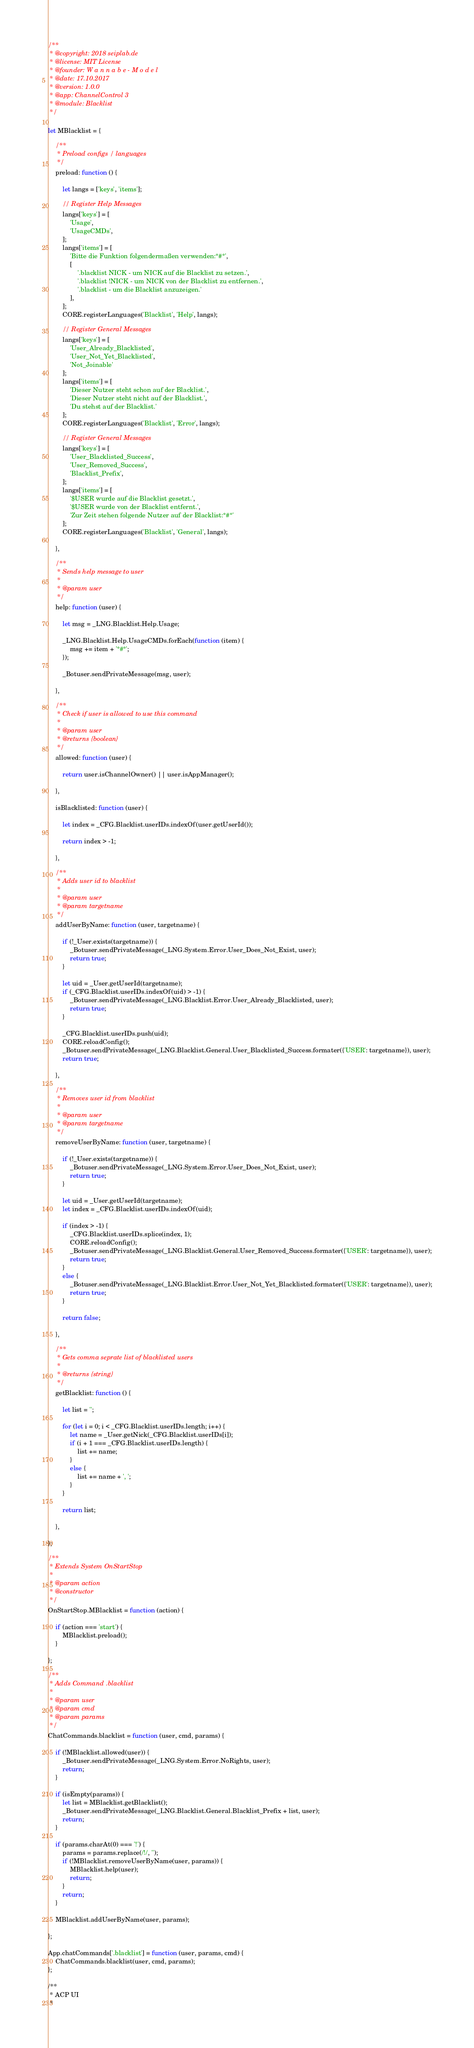<code> <loc_0><loc_0><loc_500><loc_500><_JavaScript_>/**
 * @copyright: 2018 seiplab.de
 * @license: MIT License
 * @founder: W a n n a b e - M o d e l
 * @date: 17.10.2017
 * @version: 1.0.0
 * @app: ChannelControl 3
 * @module: Blacklist
 */

let MBlacklist = {

    /**
     * Preload configs / languages
     */
    preload: function () {

        let langs = ['keys', 'items'];

        // Register Help Messages
        langs['keys'] = [
            'Usage',
            'UsageCMDs',
        ];
        langs['items'] = [
            'Bitte die Funktion folgendermaßen verwenden:°#°',
            [
                '.blacklist NICK - um NICK auf die Blacklist zu setzen.',
                '.blacklist !NICK - um NICK von der Blacklist zu entfernen.',
                '.blacklist - um die Blacklist anzuzeigen.'
            ],
        ];
        CORE.registerLanguages('Blacklist', 'Help', langs);

        // Register General Messages
        langs['keys'] = [
            'User_Already_Blacklisted',
            'User_Not_Yet_Blacklisted',
            'Not_Joinable'
        ];
        langs['items'] = [
            'Dieser Nutzer steht schon auf der Blacklist.',
            'Dieser Nutzer steht nicht auf der Blacklist.',
            'Du stehst auf der Blacklist.'
        ];
        CORE.registerLanguages('Blacklist', 'Error', langs);

        // Register General Messages
        langs['keys'] = [
            'User_Blacklisted_Success',
            'User_Removed_Success',
            'Blacklist_Prefix',
        ];
        langs['items'] = [
            '$USER wurde auf die Blacklist gesetzt.',
            '$USER wurde von der Blacklist entfernt.',
            'Zur Zeit stehen folgende Nutzer auf der Blacklist:°#°'
        ];
        CORE.registerLanguages('Blacklist', 'General', langs);

    },

    /**
     * Sends help message to user
     *
     * @param user
     */
    help: function (user) {

        let msg = _LNG.Blacklist.Help.Usage;

        _LNG.Blacklist.Help.UsageCMDs.forEach(function (item) {
            msg += item + '°#°';
        });

        _Botuser.sendPrivateMessage(msg, user);

    },

    /**
     * Check if user is allowed to use this command
     *
     * @param user
     * @returns {boolean}
     */
    allowed: function (user) {

        return user.isChannelOwner() || user.isAppManager();

    },

    isBlacklisted: function (user) {

        let index = _CFG.Blacklist.userIDs.indexOf(user.getUserId());

        return index > -1;

    },

    /**
     * Adds user id to blacklist
     *
     * @param user
     * @param targetname
     */
    addUserByName: function (user, targetname) {

        if (!_User.exists(targetname)) {
            _Botuser.sendPrivateMessage(_LNG.System.Error.User_Does_Not_Exist, user);
            return true;
        }

        let uid = _User.getUserId(targetname);
        if (_CFG.Blacklist.userIDs.indexOf(uid) > -1) {
            _Botuser.sendPrivateMessage(_LNG.Blacklist.Error.User_Already_Blacklisted, user);
            return true;
        }

        _CFG.Blacklist.userIDs.push(uid);
        CORE.reloadConfig();
        _Botuser.sendPrivateMessage(_LNG.Blacklist.General.User_Blacklisted_Success.formater({'USER': targetname}), user);
        return true;

    },

    /**
     * Removes user id from blacklist
     *
     * @param user
     * @param targetname
     */
    removeUserByName: function (user, targetname) {

        if (!_User.exists(targetname)) {
            _Botuser.sendPrivateMessage(_LNG.System.Error.User_Does_Not_Exist, user);
            return true;
        }

        let uid = _User.getUserId(targetname);
        let index = _CFG.Blacklist.userIDs.indexOf(uid);

        if (index > -1) {
            _CFG.Blacklist.userIDs.splice(index, 1);
            CORE.reloadConfig();
            _Botuser.sendPrivateMessage(_LNG.Blacklist.General.User_Removed_Success.formater({'USER': targetname}), user);
            return true;
        }
        else {
            _Botuser.sendPrivateMessage(_LNG.Blacklist.Error.User_Not_Yet_Blacklisted.formater({'USER': targetname}), user);
            return true;
        }

        return false;

    },

    /**
     * Gets comma seprate list of blacklisted users
     *
     * @returns {string}
     */
    getBlacklist: function () {

        let list = '';

        for (let i = 0; i < _CFG.Blacklist.userIDs.length; i++) {
            let name = _User.getNick(_CFG.Blacklist.userIDs[i]);
            if (i + 1 === _CFG.Blacklist.userIDs.length) {
                list += name;
            }
            else {
                list += name + ', ';
            }
        }

        return list;

    },

};

/**
 * Extends System OnStartStop
 *
 * @param action
 * @constructor
 */
OnStartStop.MBlacklist = function (action) {

    if (action === 'start') {
        MBlacklist.preload();
    }

};

/**
 * Adds Command .blacklist
 *
 * @param user
 * @param cmd
 * @param params
 */
ChatCommands.blacklist = function (user, cmd, params) {

    if (!MBlacklist.allowed(user)) {
        _Botuser.sendPrivateMessage(_LNG.System.Error.NoRights, user);
        return;
    }

    if (isEmpty(params)) {
        let list = MBlacklist.getBlacklist();
        _Botuser.sendPrivateMessage(_LNG.Blacklist.General.Blacklist_Prefix + list, user);
        return;
    }

    if (params.charAt(0) === '!') {
        params = params.replace(/!/, '');
        if (!MBlacklist.removeUserByName(user, params)) {
            MBlacklist.help(user);
            return;
        }
        return;
    }

    MBlacklist.addUserByName(user, params);

};

App.chatCommands['.blacklist'] = function (user, params, cmd) {
    ChatCommands.blacklist(user, cmd, params);
};

/**
 * ACP UI
 *</code> 